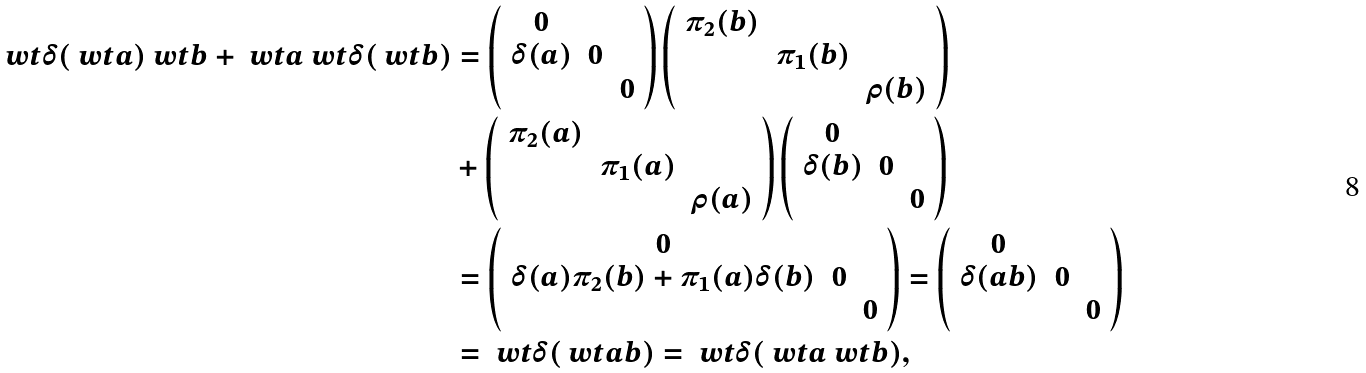Convert formula to latex. <formula><loc_0><loc_0><loc_500><loc_500>\ w t { \delta } ( \ w t { a } ) \ w t { b } + \ w t { a } \ w t { \delta } ( \ w t { b } ) & = \left ( \begin{array} { c c c } 0 & & \\ \delta ( a ) & 0 & \\ & & 0 \end{array} \right ) \left ( \begin{array} { c c c } \pi _ { 2 } ( b ) & & \\ & \pi _ { 1 } ( b ) & \\ & & \rho ( b ) \end{array} \right ) \\ & + \left ( \begin{array} { c c c } \pi _ { 2 } ( a ) & & \\ & \pi _ { 1 } ( a ) & \\ & & \rho ( a ) \end{array} \right ) \left ( \begin{array} { c c c } 0 & & \\ \delta ( b ) & 0 & \\ & & 0 \end{array} \right ) \\ & = \left ( \begin{array} { c c c } 0 & & \\ \delta ( a ) \pi _ { 2 } ( b ) + \pi _ { 1 } ( a ) \delta ( b ) & 0 & \\ & & 0 \end{array} \right ) = \left ( \begin{array} { c c c } 0 & & \\ \delta ( a b ) & 0 & \\ & & 0 \end{array} \right ) \\ & = \ w t { \delta } ( \ w t { a b } ) = \ w t { \delta } ( \ w t { a } \ w t { b } ) ,</formula> 